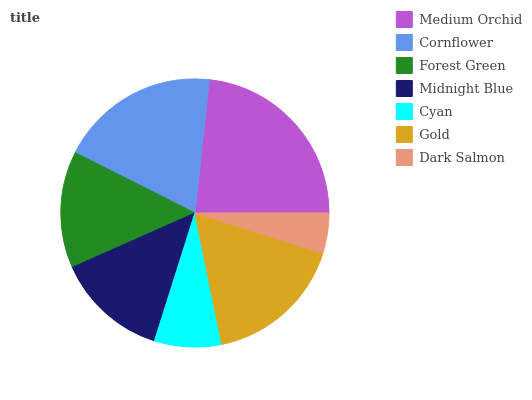Is Dark Salmon the minimum?
Answer yes or no. Yes. Is Medium Orchid the maximum?
Answer yes or no. Yes. Is Cornflower the minimum?
Answer yes or no. No. Is Cornflower the maximum?
Answer yes or no. No. Is Medium Orchid greater than Cornflower?
Answer yes or no. Yes. Is Cornflower less than Medium Orchid?
Answer yes or no. Yes. Is Cornflower greater than Medium Orchid?
Answer yes or no. No. Is Medium Orchid less than Cornflower?
Answer yes or no. No. Is Forest Green the high median?
Answer yes or no. Yes. Is Forest Green the low median?
Answer yes or no. Yes. Is Dark Salmon the high median?
Answer yes or no. No. Is Midnight Blue the low median?
Answer yes or no. No. 